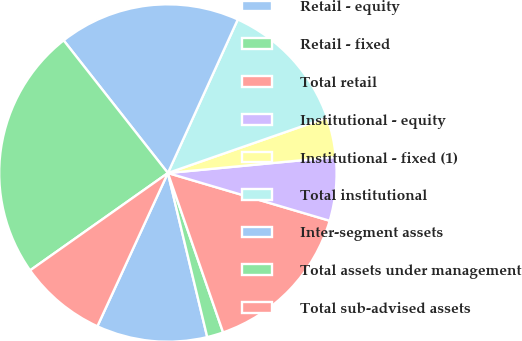Convert chart to OTSL. <chart><loc_0><loc_0><loc_500><loc_500><pie_chart><fcel>Retail - equity<fcel>Retail - fixed<fcel>Total retail<fcel>Institutional - equity<fcel>Institutional - fixed (1)<fcel>Total institutional<fcel>Inter-segment assets<fcel>Total assets under management<fcel>Total sub-advised assets<nl><fcel>10.61%<fcel>1.56%<fcel>15.13%<fcel>6.08%<fcel>3.82%<fcel>12.87%<fcel>17.4%<fcel>24.19%<fcel>8.35%<nl></chart> 